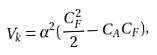Convert formula to latex. <formula><loc_0><loc_0><loc_500><loc_500>V _ { k } = \alpha ^ { 2 } ( \frac { C _ { F } ^ { 2 } } { 2 } - C _ { A } C _ { F } ) ,</formula> 